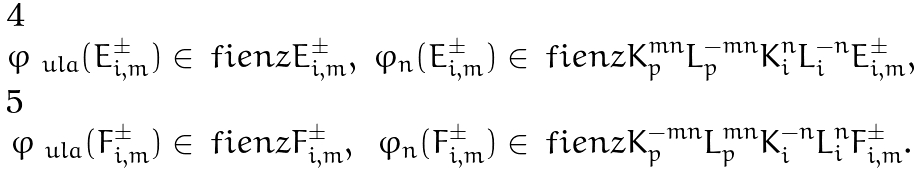<formula> <loc_0><loc_0><loc_500><loc_500>\varphi _ { \ u l a } ( E ^ { \pm } _ { i , m } ) \in & \, \ f i e n z E ^ { \pm } _ { i , m } , & \varphi _ { n } ( E ^ { \pm } _ { i , m } ) \in & \, \ f i e n z K _ { p } ^ { m n } L _ { p } ^ { - m n } K _ { i } ^ { n } L _ { i } ^ { - n } E ^ { \pm } _ { i , m } , \\ \varphi _ { \ u l a } ( F ^ { \pm } _ { i , m } ) \in & \, \ f i e n z F ^ { \pm } _ { i , m } , & \varphi _ { n } ( F ^ { \pm } _ { i , m } ) \in & \, \ f i e n z K _ { p } ^ { - m n } L _ { p } ^ { m n } K _ { i } ^ { - n } L _ { i } ^ { n } F ^ { \pm } _ { i , m } .</formula> 